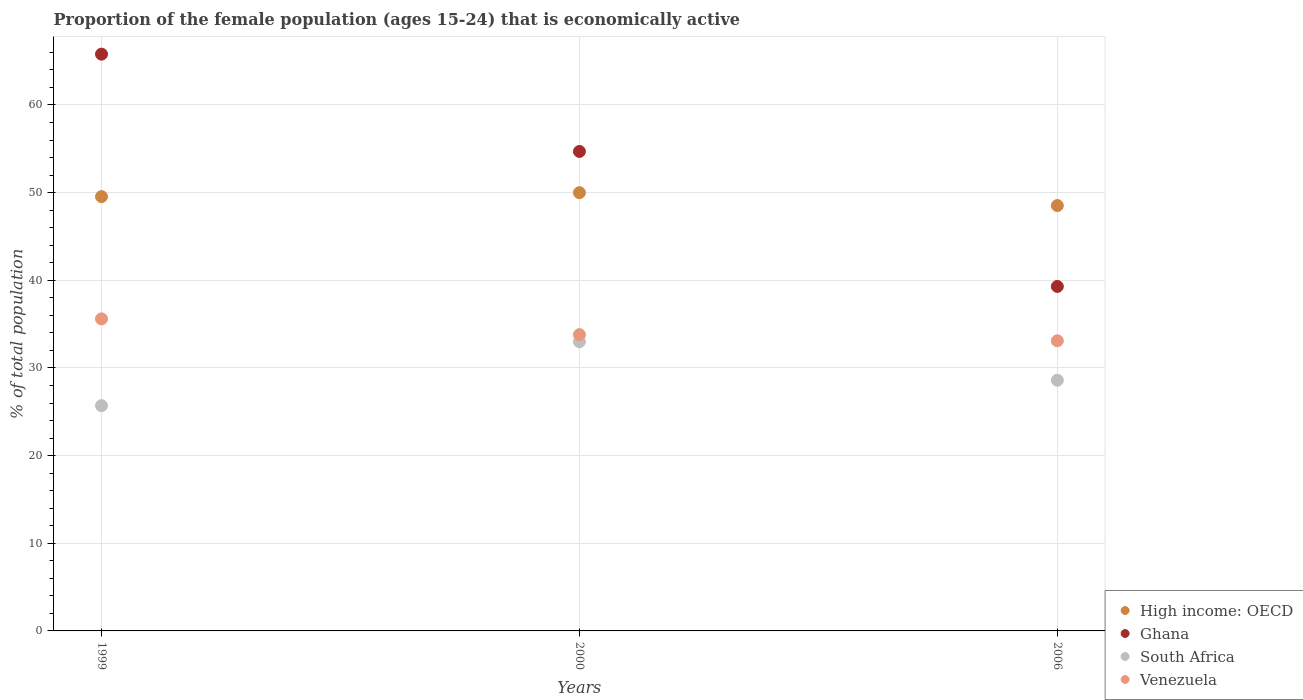What is the proportion of the female population that is economically active in High income: OECD in 2000?
Make the answer very short. 50. Across all years, what is the minimum proportion of the female population that is economically active in South Africa?
Provide a succinct answer. 25.7. What is the total proportion of the female population that is economically active in High income: OECD in the graph?
Ensure brevity in your answer.  148.07. What is the difference between the proportion of the female population that is economically active in High income: OECD in 1999 and that in 2000?
Make the answer very short. -0.45. What is the difference between the proportion of the female population that is economically active in Ghana in 2006 and the proportion of the female population that is economically active in Venezuela in 1999?
Offer a very short reply. 3.7. What is the average proportion of the female population that is economically active in High income: OECD per year?
Your response must be concise. 49.36. In the year 2000, what is the difference between the proportion of the female population that is economically active in South Africa and proportion of the female population that is economically active in Ghana?
Offer a very short reply. -21.7. What is the ratio of the proportion of the female population that is economically active in High income: OECD in 1999 to that in 2000?
Your answer should be very brief. 0.99. Is the proportion of the female population that is economically active in Ghana in 1999 less than that in 2006?
Ensure brevity in your answer.  No. Is the difference between the proportion of the female population that is economically active in South Africa in 2000 and 2006 greater than the difference between the proportion of the female population that is economically active in Ghana in 2000 and 2006?
Offer a terse response. No. What is the difference between the highest and the second highest proportion of the female population that is economically active in Venezuela?
Keep it short and to the point. 1.8. What is the difference between the highest and the lowest proportion of the female population that is economically active in South Africa?
Offer a very short reply. 7.3. Is the sum of the proportion of the female population that is economically active in Venezuela in 1999 and 2000 greater than the maximum proportion of the female population that is economically active in South Africa across all years?
Ensure brevity in your answer.  Yes. Is it the case that in every year, the sum of the proportion of the female population that is economically active in Venezuela and proportion of the female population that is economically active in Ghana  is greater than the proportion of the female population that is economically active in High income: OECD?
Your response must be concise. Yes. Is the proportion of the female population that is economically active in South Africa strictly less than the proportion of the female population that is economically active in Venezuela over the years?
Keep it short and to the point. Yes. How many dotlines are there?
Your answer should be very brief. 4. Are the values on the major ticks of Y-axis written in scientific E-notation?
Provide a short and direct response. No. Does the graph contain grids?
Ensure brevity in your answer.  Yes. How many legend labels are there?
Keep it short and to the point. 4. What is the title of the graph?
Make the answer very short. Proportion of the female population (ages 15-24) that is economically active. Does "Middle East & North Africa (developing only)" appear as one of the legend labels in the graph?
Your answer should be compact. No. What is the label or title of the Y-axis?
Offer a terse response. % of total population. What is the % of total population of High income: OECD in 1999?
Offer a terse response. 49.55. What is the % of total population in Ghana in 1999?
Your answer should be compact. 65.8. What is the % of total population in South Africa in 1999?
Your answer should be compact. 25.7. What is the % of total population of Venezuela in 1999?
Provide a succinct answer. 35.6. What is the % of total population of High income: OECD in 2000?
Your response must be concise. 50. What is the % of total population of Ghana in 2000?
Your answer should be compact. 54.7. What is the % of total population in Venezuela in 2000?
Provide a short and direct response. 33.8. What is the % of total population in High income: OECD in 2006?
Provide a succinct answer. 48.53. What is the % of total population of Ghana in 2006?
Provide a succinct answer. 39.3. What is the % of total population in South Africa in 2006?
Offer a terse response. 28.6. What is the % of total population of Venezuela in 2006?
Provide a succinct answer. 33.1. Across all years, what is the maximum % of total population of High income: OECD?
Give a very brief answer. 50. Across all years, what is the maximum % of total population of Ghana?
Keep it short and to the point. 65.8. Across all years, what is the maximum % of total population of South Africa?
Your response must be concise. 33. Across all years, what is the maximum % of total population of Venezuela?
Your response must be concise. 35.6. Across all years, what is the minimum % of total population in High income: OECD?
Your answer should be compact. 48.53. Across all years, what is the minimum % of total population in Ghana?
Offer a very short reply. 39.3. Across all years, what is the minimum % of total population in South Africa?
Provide a succinct answer. 25.7. Across all years, what is the minimum % of total population of Venezuela?
Offer a very short reply. 33.1. What is the total % of total population in High income: OECD in the graph?
Give a very brief answer. 148.07. What is the total % of total population of Ghana in the graph?
Give a very brief answer. 159.8. What is the total % of total population of South Africa in the graph?
Provide a succinct answer. 87.3. What is the total % of total population of Venezuela in the graph?
Ensure brevity in your answer.  102.5. What is the difference between the % of total population in High income: OECD in 1999 and that in 2000?
Offer a very short reply. -0.45. What is the difference between the % of total population of South Africa in 1999 and that in 2000?
Offer a terse response. -7.3. What is the difference between the % of total population in High income: OECD in 1999 and that in 2006?
Your answer should be very brief. 1.02. What is the difference between the % of total population in Venezuela in 1999 and that in 2006?
Provide a succinct answer. 2.5. What is the difference between the % of total population of High income: OECD in 2000 and that in 2006?
Provide a succinct answer. 1.47. What is the difference between the % of total population in Ghana in 2000 and that in 2006?
Ensure brevity in your answer.  15.4. What is the difference between the % of total population of South Africa in 2000 and that in 2006?
Your answer should be very brief. 4.4. What is the difference between the % of total population in Venezuela in 2000 and that in 2006?
Give a very brief answer. 0.7. What is the difference between the % of total population of High income: OECD in 1999 and the % of total population of Ghana in 2000?
Give a very brief answer. -5.15. What is the difference between the % of total population of High income: OECD in 1999 and the % of total population of South Africa in 2000?
Your answer should be compact. 16.55. What is the difference between the % of total population of High income: OECD in 1999 and the % of total population of Venezuela in 2000?
Make the answer very short. 15.75. What is the difference between the % of total population of Ghana in 1999 and the % of total population of South Africa in 2000?
Ensure brevity in your answer.  32.8. What is the difference between the % of total population of Ghana in 1999 and the % of total population of Venezuela in 2000?
Give a very brief answer. 32. What is the difference between the % of total population in South Africa in 1999 and the % of total population in Venezuela in 2000?
Your response must be concise. -8.1. What is the difference between the % of total population in High income: OECD in 1999 and the % of total population in Ghana in 2006?
Ensure brevity in your answer.  10.25. What is the difference between the % of total population of High income: OECD in 1999 and the % of total population of South Africa in 2006?
Offer a terse response. 20.95. What is the difference between the % of total population of High income: OECD in 1999 and the % of total population of Venezuela in 2006?
Your answer should be very brief. 16.45. What is the difference between the % of total population in Ghana in 1999 and the % of total population in South Africa in 2006?
Your answer should be very brief. 37.2. What is the difference between the % of total population in Ghana in 1999 and the % of total population in Venezuela in 2006?
Keep it short and to the point. 32.7. What is the difference between the % of total population of South Africa in 1999 and the % of total population of Venezuela in 2006?
Make the answer very short. -7.4. What is the difference between the % of total population of High income: OECD in 2000 and the % of total population of Ghana in 2006?
Offer a very short reply. 10.7. What is the difference between the % of total population of High income: OECD in 2000 and the % of total population of South Africa in 2006?
Your answer should be compact. 21.4. What is the difference between the % of total population of High income: OECD in 2000 and the % of total population of Venezuela in 2006?
Your answer should be compact. 16.9. What is the difference between the % of total population in Ghana in 2000 and the % of total population in South Africa in 2006?
Your response must be concise. 26.1. What is the difference between the % of total population of Ghana in 2000 and the % of total population of Venezuela in 2006?
Offer a very short reply. 21.6. What is the difference between the % of total population of South Africa in 2000 and the % of total population of Venezuela in 2006?
Your answer should be very brief. -0.1. What is the average % of total population of High income: OECD per year?
Offer a terse response. 49.36. What is the average % of total population in Ghana per year?
Your answer should be very brief. 53.27. What is the average % of total population of South Africa per year?
Offer a very short reply. 29.1. What is the average % of total population of Venezuela per year?
Offer a terse response. 34.17. In the year 1999, what is the difference between the % of total population in High income: OECD and % of total population in Ghana?
Your answer should be very brief. -16.25. In the year 1999, what is the difference between the % of total population of High income: OECD and % of total population of South Africa?
Your answer should be compact. 23.85. In the year 1999, what is the difference between the % of total population of High income: OECD and % of total population of Venezuela?
Your answer should be very brief. 13.95. In the year 1999, what is the difference between the % of total population of Ghana and % of total population of South Africa?
Your response must be concise. 40.1. In the year 1999, what is the difference between the % of total population in Ghana and % of total population in Venezuela?
Give a very brief answer. 30.2. In the year 2000, what is the difference between the % of total population of High income: OECD and % of total population of Ghana?
Offer a terse response. -4.7. In the year 2000, what is the difference between the % of total population in High income: OECD and % of total population in South Africa?
Ensure brevity in your answer.  17. In the year 2000, what is the difference between the % of total population in High income: OECD and % of total population in Venezuela?
Provide a short and direct response. 16.2. In the year 2000, what is the difference between the % of total population of Ghana and % of total population of South Africa?
Your response must be concise. 21.7. In the year 2000, what is the difference between the % of total population in Ghana and % of total population in Venezuela?
Provide a short and direct response. 20.9. In the year 2006, what is the difference between the % of total population of High income: OECD and % of total population of Ghana?
Ensure brevity in your answer.  9.23. In the year 2006, what is the difference between the % of total population in High income: OECD and % of total population in South Africa?
Your response must be concise. 19.93. In the year 2006, what is the difference between the % of total population in High income: OECD and % of total population in Venezuela?
Provide a succinct answer. 15.43. In the year 2006, what is the difference between the % of total population of Ghana and % of total population of South Africa?
Your response must be concise. 10.7. In the year 2006, what is the difference between the % of total population of Ghana and % of total population of Venezuela?
Make the answer very short. 6.2. In the year 2006, what is the difference between the % of total population of South Africa and % of total population of Venezuela?
Give a very brief answer. -4.5. What is the ratio of the % of total population in High income: OECD in 1999 to that in 2000?
Your answer should be very brief. 0.99. What is the ratio of the % of total population in Ghana in 1999 to that in 2000?
Offer a terse response. 1.2. What is the ratio of the % of total population of South Africa in 1999 to that in 2000?
Offer a terse response. 0.78. What is the ratio of the % of total population in Venezuela in 1999 to that in 2000?
Keep it short and to the point. 1.05. What is the ratio of the % of total population in Ghana in 1999 to that in 2006?
Your answer should be very brief. 1.67. What is the ratio of the % of total population in South Africa in 1999 to that in 2006?
Provide a short and direct response. 0.9. What is the ratio of the % of total population of Venezuela in 1999 to that in 2006?
Keep it short and to the point. 1.08. What is the ratio of the % of total population in High income: OECD in 2000 to that in 2006?
Provide a short and direct response. 1.03. What is the ratio of the % of total population in Ghana in 2000 to that in 2006?
Keep it short and to the point. 1.39. What is the ratio of the % of total population in South Africa in 2000 to that in 2006?
Ensure brevity in your answer.  1.15. What is the ratio of the % of total population of Venezuela in 2000 to that in 2006?
Provide a short and direct response. 1.02. What is the difference between the highest and the second highest % of total population of High income: OECD?
Offer a terse response. 0.45. What is the difference between the highest and the second highest % of total population of South Africa?
Provide a succinct answer. 4.4. What is the difference between the highest and the lowest % of total population of High income: OECD?
Your answer should be very brief. 1.47. What is the difference between the highest and the lowest % of total population of Venezuela?
Your response must be concise. 2.5. 